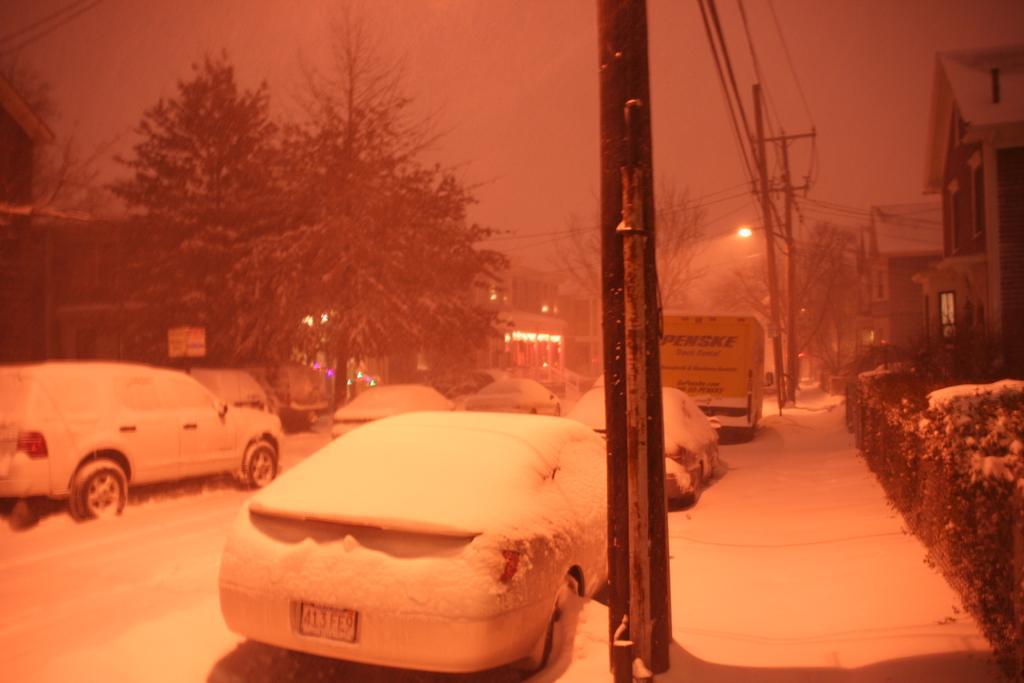In one or two sentences, can you explain what this image depicts? This image consists of many cars parked on the road. And we can see the snow. In the background, there are trees and poles. On the right, there are buildings. 